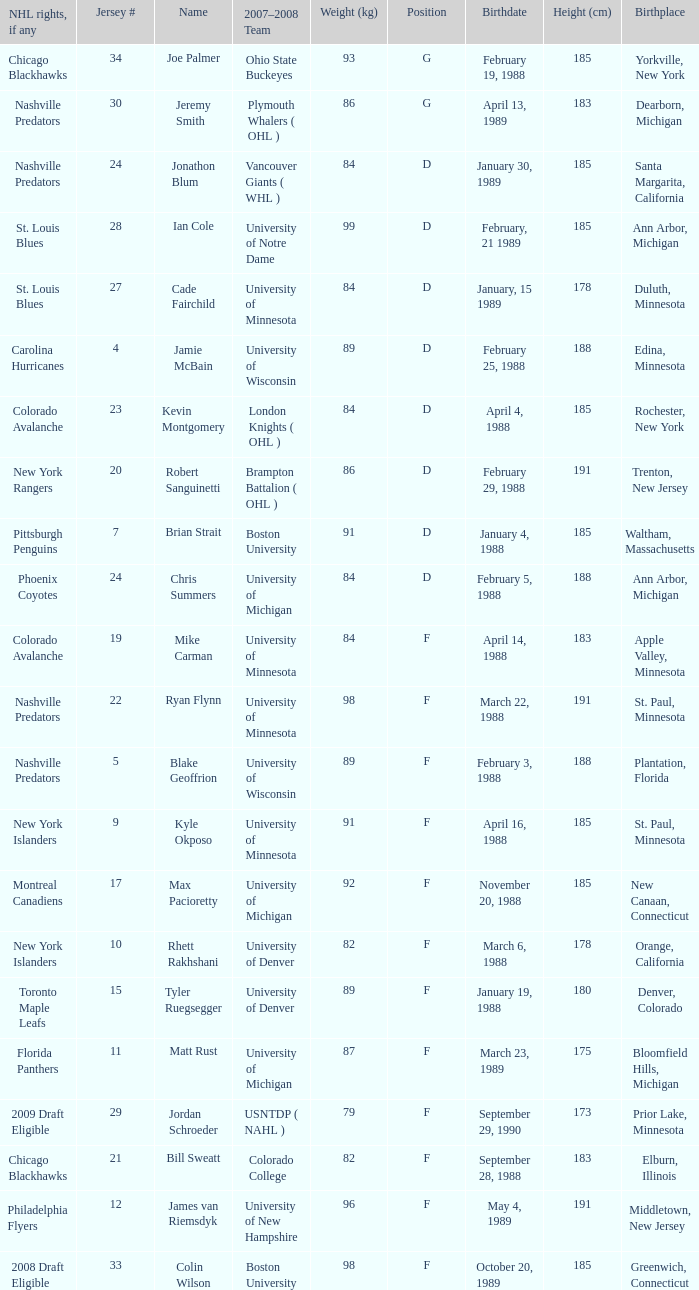From bloomfield hills, michigan, what height in centimeters is a person likely to have? 175.0. 